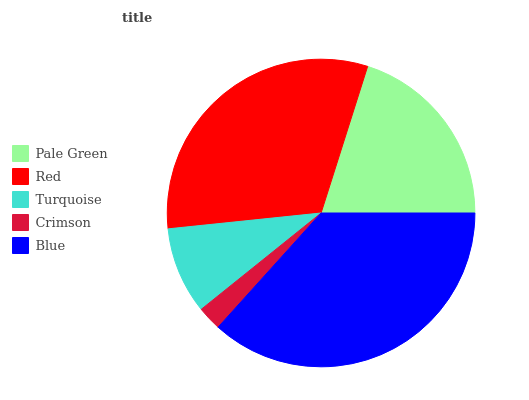Is Crimson the minimum?
Answer yes or no. Yes. Is Blue the maximum?
Answer yes or no. Yes. Is Red the minimum?
Answer yes or no. No. Is Red the maximum?
Answer yes or no. No. Is Red greater than Pale Green?
Answer yes or no. Yes. Is Pale Green less than Red?
Answer yes or no. Yes. Is Pale Green greater than Red?
Answer yes or no. No. Is Red less than Pale Green?
Answer yes or no. No. Is Pale Green the high median?
Answer yes or no. Yes. Is Pale Green the low median?
Answer yes or no. Yes. Is Red the high median?
Answer yes or no. No. Is Crimson the low median?
Answer yes or no. No. 